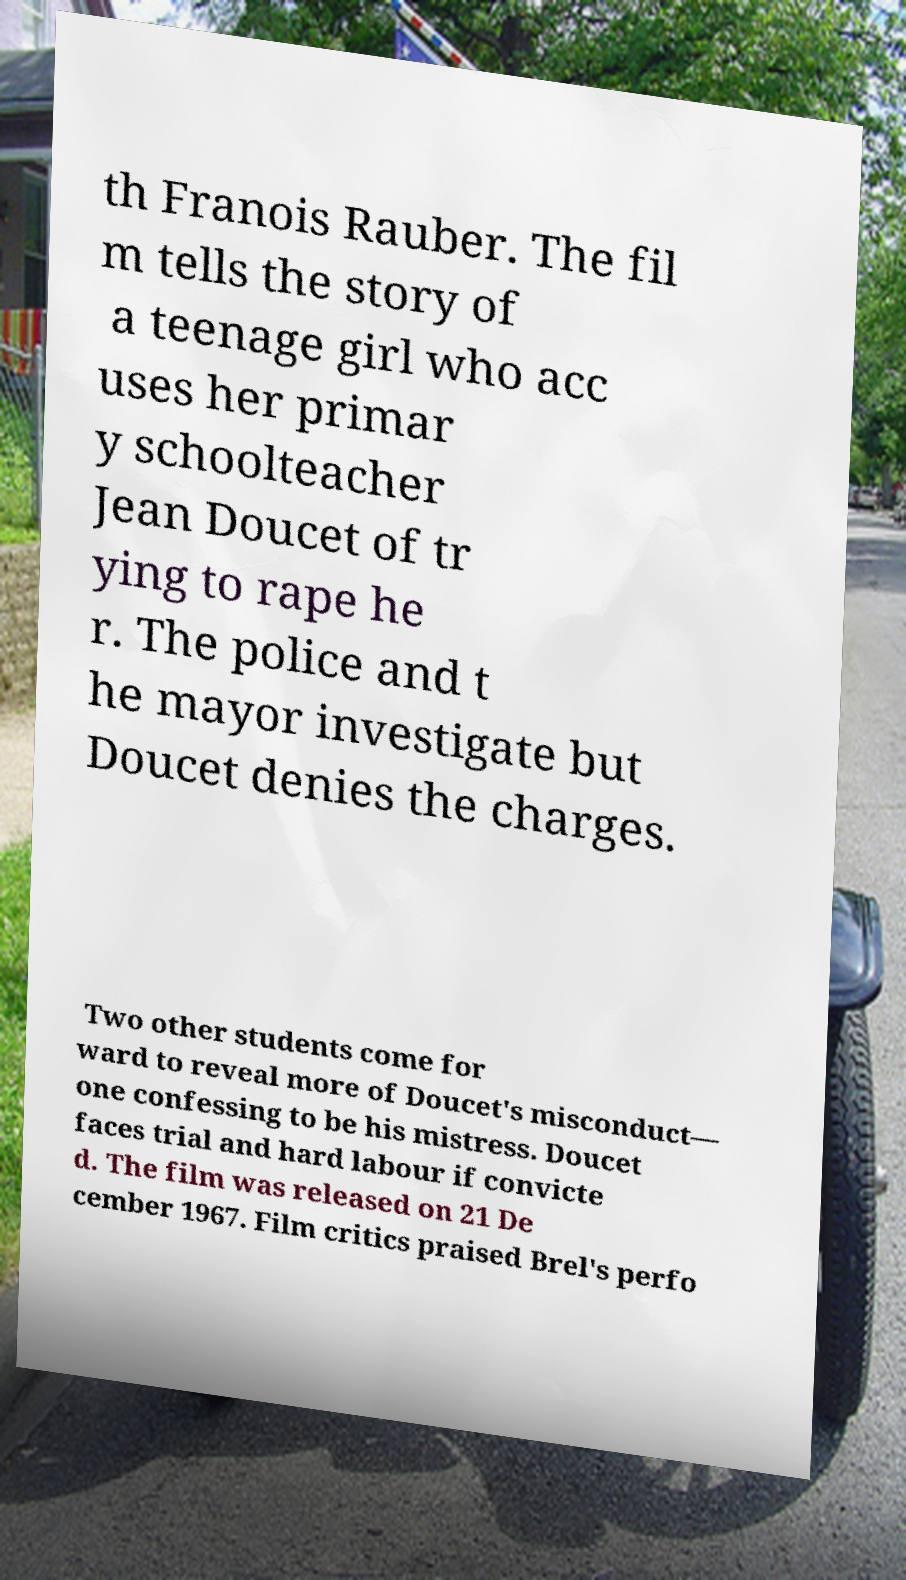Could you assist in decoding the text presented in this image and type it out clearly? th Franois Rauber. The fil m tells the story of a teenage girl who acc uses her primar y schoolteacher Jean Doucet of tr ying to rape he r. The police and t he mayor investigate but Doucet denies the charges. Two other students come for ward to reveal more of Doucet's misconduct— one confessing to be his mistress. Doucet faces trial and hard labour if convicte d. The film was released on 21 De cember 1967. Film critics praised Brel's perfo 